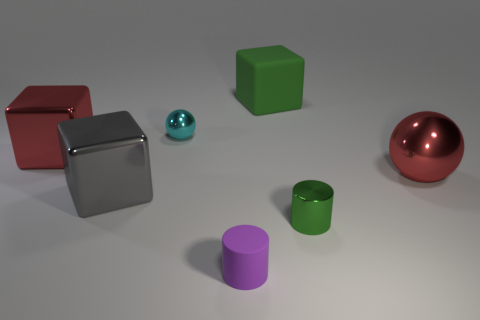The metallic thing that is the same size as the green metal cylinder is what color?
Provide a succinct answer. Cyan. There is a rubber object that is behind the small metallic cylinder; is it the same color as the small shiny cylinder?
Keep it short and to the point. Yes. Is there any other thing that is the same color as the big ball?
Keep it short and to the point. Yes. There is a small object behind the large red thing left of the metal cylinder; what shape is it?
Your response must be concise. Sphere. Are there more big gray shiny cubes than cubes?
Provide a short and direct response. No. How many things are to the left of the small cyan metallic sphere and on the right side of the tiny matte cylinder?
Offer a terse response. 0. How many big metal things are in front of the sphere on the right side of the small purple rubber thing?
Keep it short and to the point. 1. How many things are big red objects left of the purple matte cylinder or metal spheres on the left side of the tiny green metal thing?
Provide a short and direct response. 2. There is a big green thing that is the same shape as the big gray thing; what is it made of?
Offer a very short reply. Rubber. How many things are either big metallic things right of the cyan object or metal cylinders?
Provide a short and direct response. 2. 